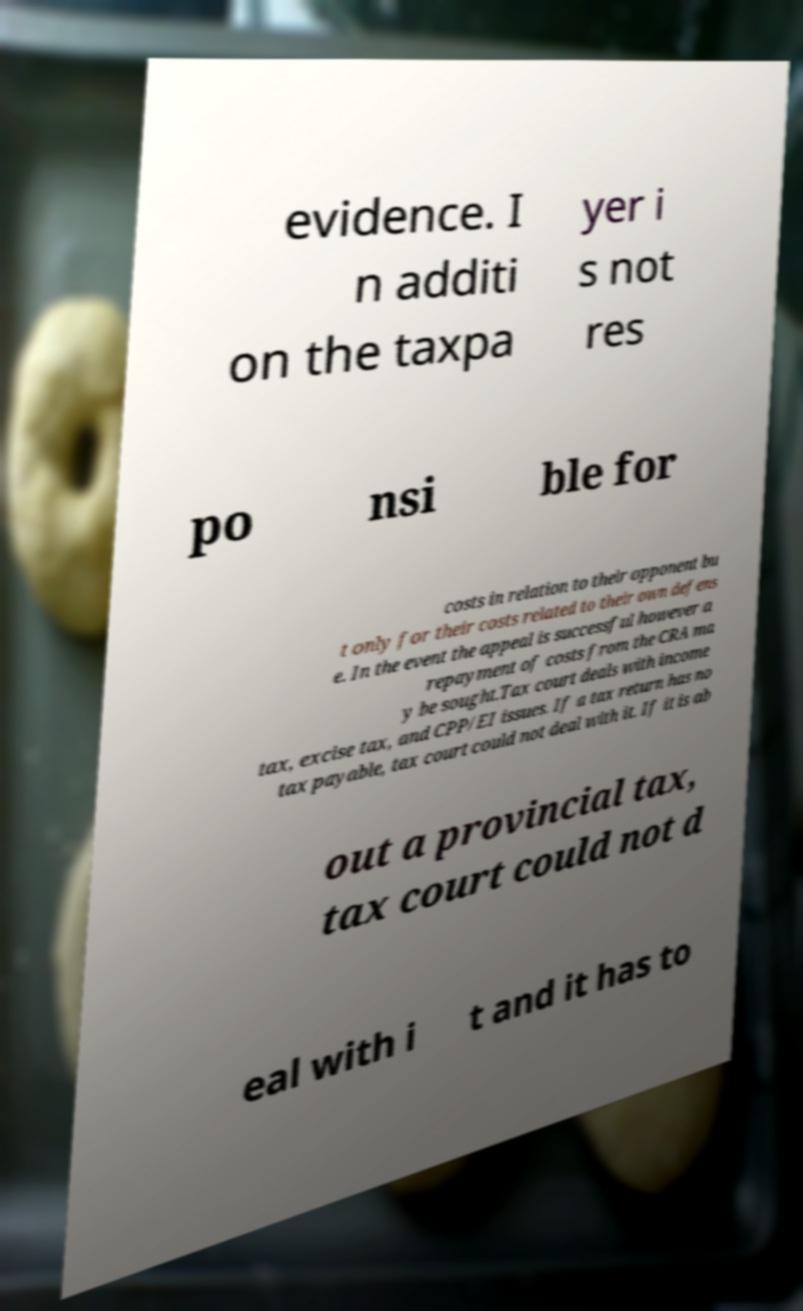Can you accurately transcribe the text from the provided image for me? evidence. I n additi on the taxpa yer i s not res po nsi ble for costs in relation to their opponent bu t only for their costs related to their own defens e. In the event the appeal is successful however a repayment of costs from the CRA ma y be sought.Tax court deals with income tax, excise tax, and CPP/EI issues. If a tax return has no tax payable, tax court could not deal with it. If it is ab out a provincial tax, tax court could not d eal with i t and it has to 